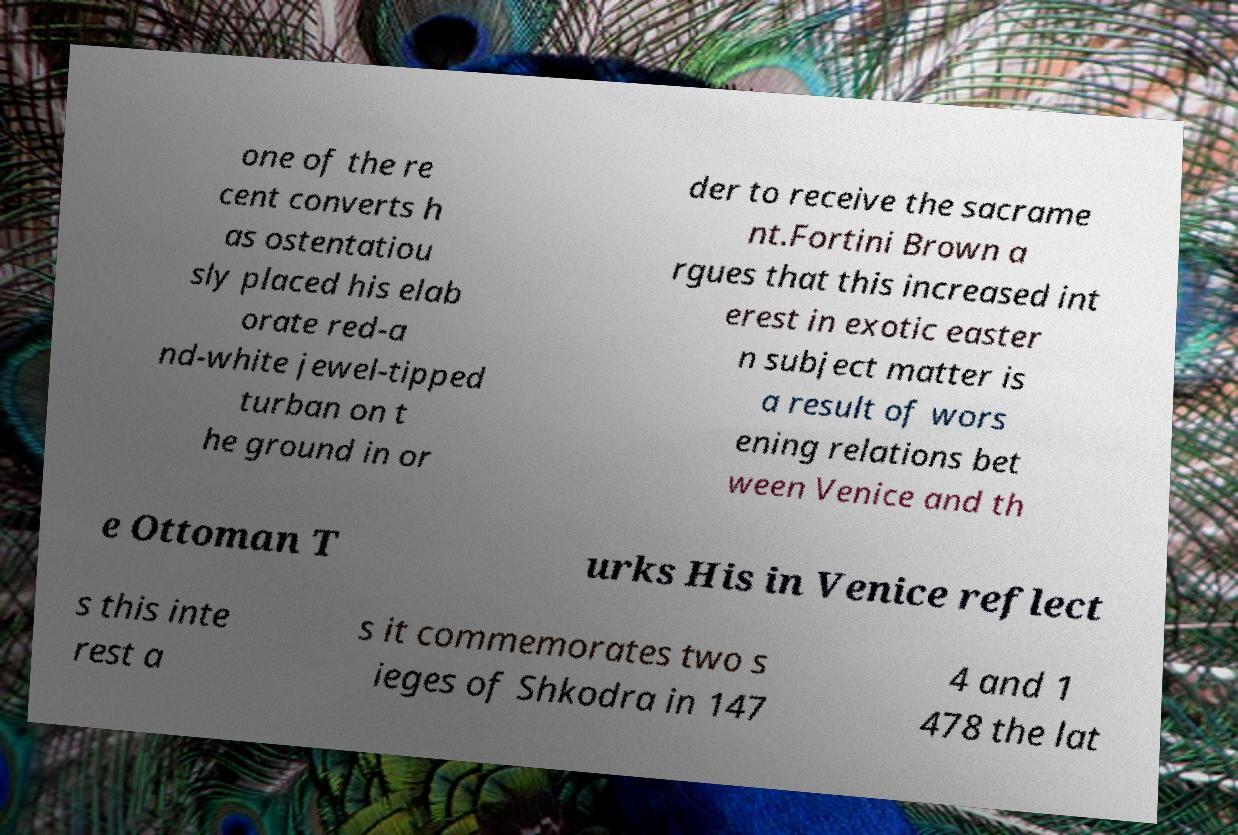There's text embedded in this image that I need extracted. Can you transcribe it verbatim? one of the re cent converts h as ostentatiou sly placed his elab orate red-a nd-white jewel-tipped turban on t he ground in or der to receive the sacrame nt.Fortini Brown a rgues that this increased int erest in exotic easter n subject matter is a result of wors ening relations bet ween Venice and th e Ottoman T urks His in Venice reflect s this inte rest a s it commemorates two s ieges of Shkodra in 147 4 and 1 478 the lat 